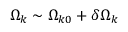Convert formula to latex. <formula><loc_0><loc_0><loc_500><loc_500>\Omega _ { k } \sim \Omega _ { k 0 } + \delta \Omega _ { k }</formula> 